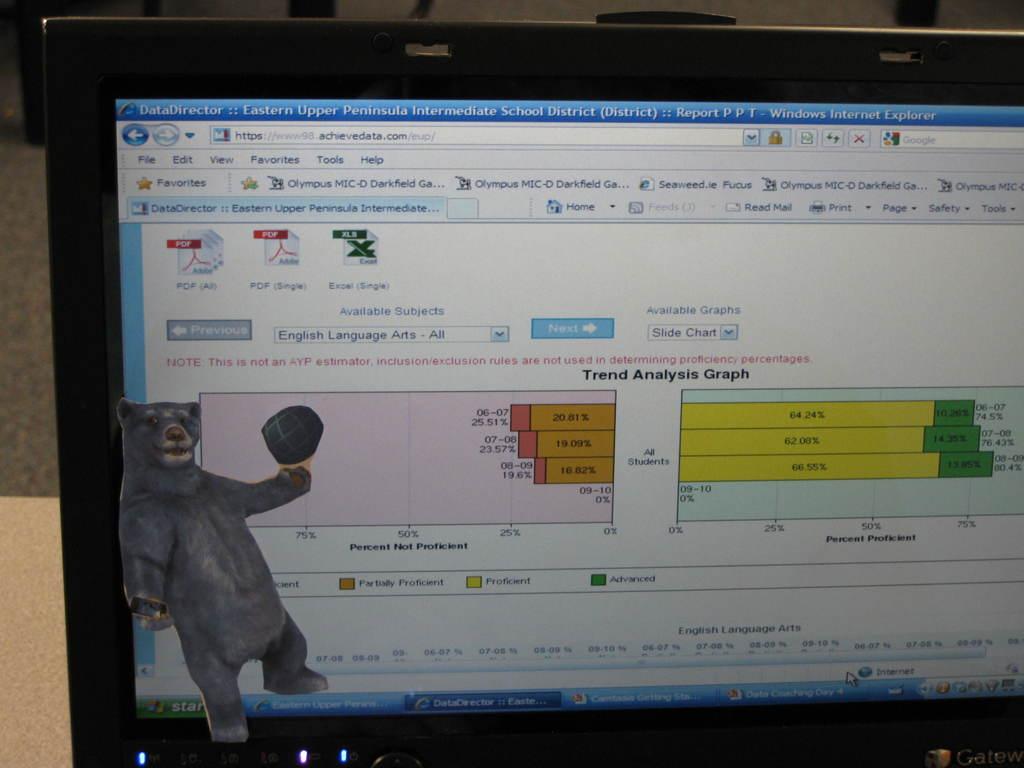What kind of graphs are these?
Your response must be concise. Trend analysis. 